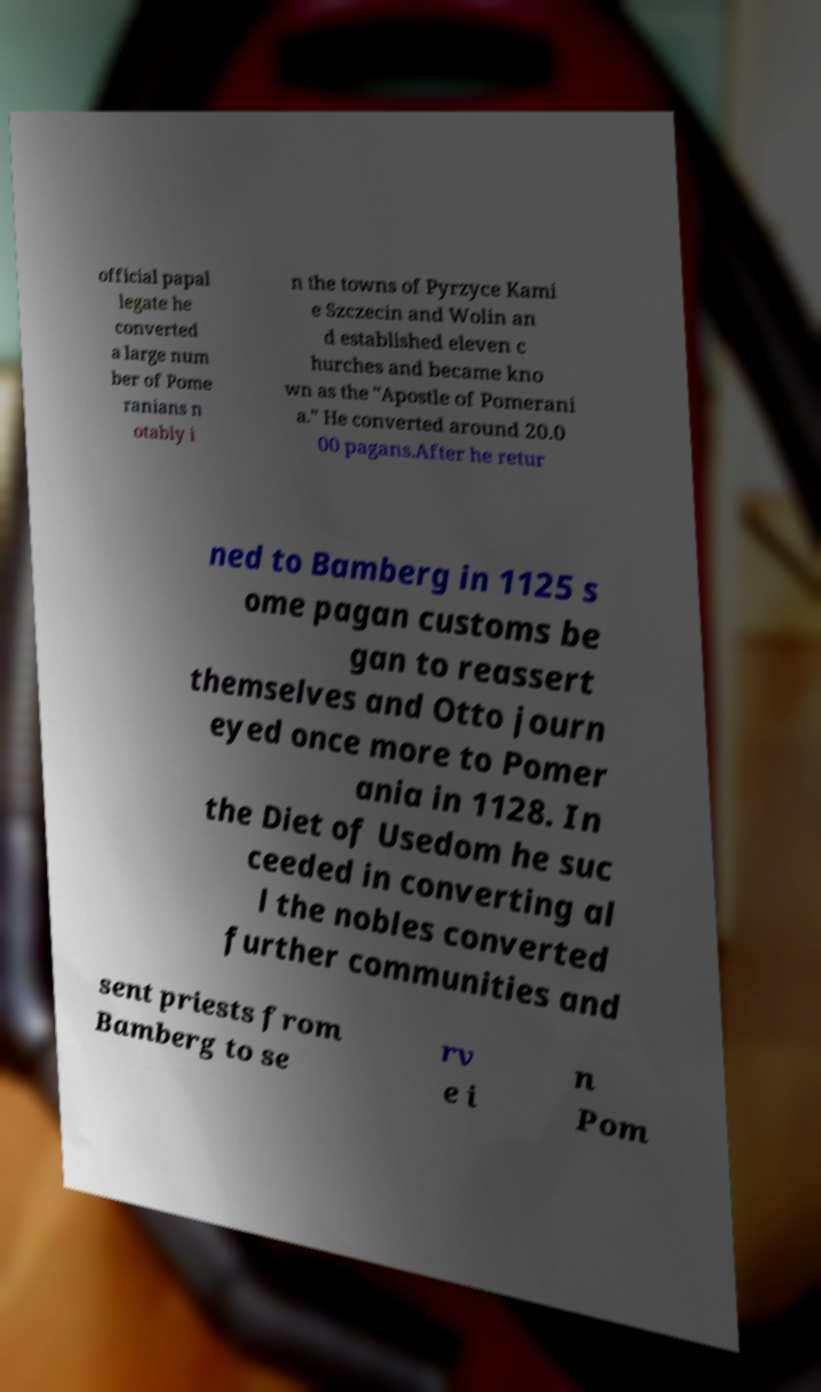Please identify and transcribe the text found in this image. official papal legate he converted a large num ber of Pome ranians n otably i n the towns of Pyrzyce Kami e Szczecin and Wolin an d established eleven c hurches and became kno wn as the "Apostle of Pomerani a." He converted around 20.0 00 pagans.After he retur ned to Bamberg in 1125 s ome pagan customs be gan to reassert themselves and Otto journ eyed once more to Pomer ania in 1128. In the Diet of Usedom he suc ceeded in converting al l the nobles converted further communities and sent priests from Bamberg to se rv e i n Pom 